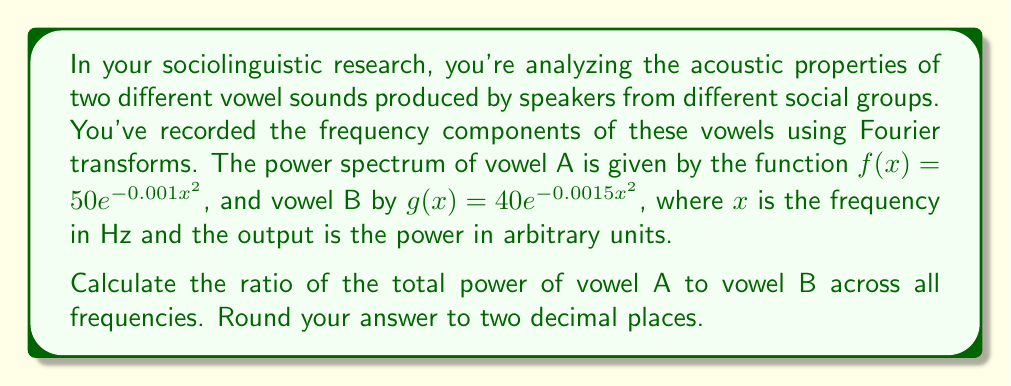Give your solution to this math problem. To solve this problem, we need to follow these steps:

1) The total power of a vowel sound is given by the integral of its power spectrum function over all frequencies (from 0 to infinity).

2) For vowel A: $\int_0^\infty f(x)dx = \int_0^\infty 50e^{-0.001x^2}dx$
   For vowel B: $\int_0^\infty g(x)dx = \int_0^\infty 40e^{-0.0015x^2}dx$

3) These integrals are of the form $\int_0^\infty ae^{-bx^2}dx$, which has a known solution:
   $\int_0^\infty ae^{-bx^2}dx = a\sqrt{\frac{\pi}{4b}}$

4) For vowel A: 
   $\int_0^\infty 50e^{-0.001x^2}dx = 50\sqrt{\frac{\pi}{4(0.001)}} = 50\sqrt{\frac{\pi}{0.004}} = 1250\sqrt{\pi}$

5) For vowel B:
   $\int_0^\infty 40e^{-0.0015x^2}dx = 40\sqrt{\frac{\pi}{4(0.0015)}} = 40\sqrt{\frac{\pi}{0.006}} = \frac{1000\sqrt{\pi}}{\sqrt{1.5}}$

6) The ratio of the total power of vowel A to vowel B is:

   $\frac{\text{Power of A}}{\text{Power of B}} = \frac{1250\sqrt{\pi}}{\frac{1000\sqrt{\pi}}{\sqrt{1.5}}} = \frac{1250\sqrt{1.5}}{1000} = 1.5309...$

7) Rounding to two decimal places gives 1.53.
Answer: 1.53 